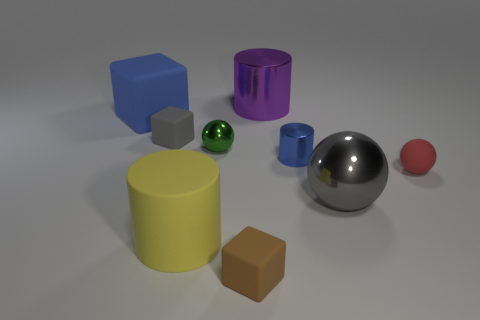There is a tiny shiny object that is the same color as the big matte cube; what is its shape?
Your response must be concise. Cylinder. What material is the cylinder that is in front of the rubber thing that is right of the big purple metallic cylinder that is behind the big yellow cylinder made of?
Offer a terse response. Rubber. How many metallic cylinders are on the right side of the tiny brown matte object to the left of the red rubber thing?
Make the answer very short. 2. Do the blue object in front of the blue matte cube and the green shiny object have the same size?
Provide a succinct answer. Yes. How many other large things are the same shape as the green metallic object?
Offer a very short reply. 1. The tiny blue thing has what shape?
Offer a very short reply. Cylinder. Are there an equal number of gray matte cubes that are on the left side of the blue cube and small blue objects?
Keep it short and to the point. No. Does the cube in front of the matte sphere have the same material as the big yellow thing?
Provide a succinct answer. Yes. Are there fewer tiny metallic cylinders behind the purple object than small cylinders?
Make the answer very short. Yes. What number of metallic objects are either green balls or red spheres?
Your answer should be very brief. 1. 